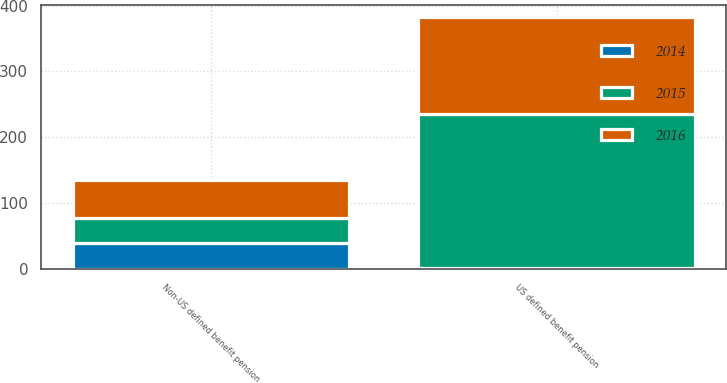Convert chart to OTSL. <chart><loc_0><loc_0><loc_500><loc_500><stacked_bar_chart><ecel><fcel>US defined benefit pension<fcel>Non-US defined benefit pension<nl><fcel>2016<fcel>146<fcel>58<nl><fcel>2015<fcel>234<fcel>39<nl><fcel>2014<fcel>2<fcel>39<nl></chart> 